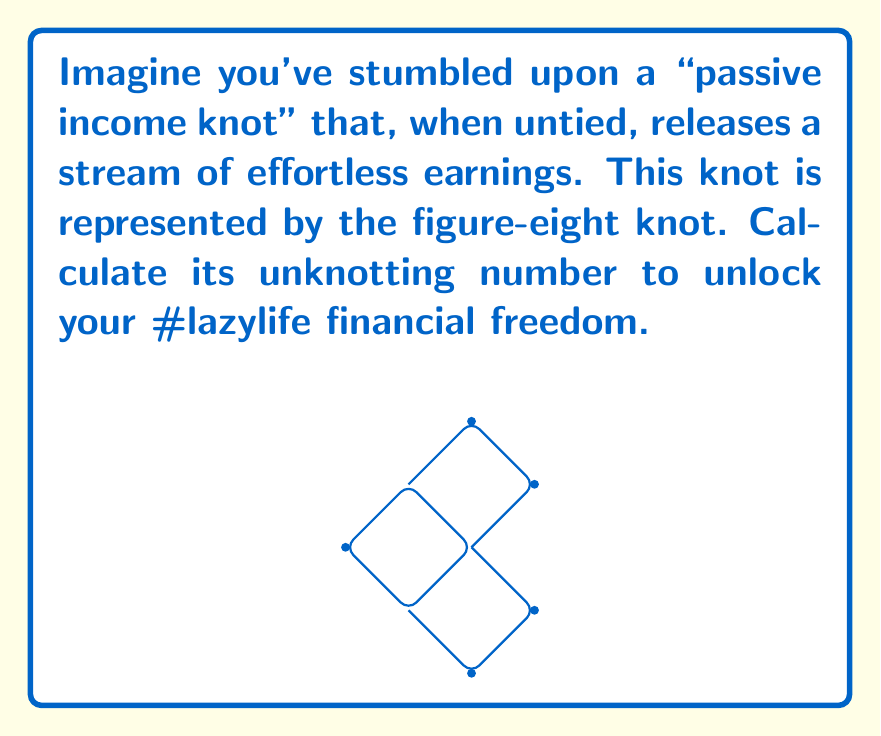Teach me how to tackle this problem. To calculate the unknotting number of the figure-eight knot, we need to follow these steps:

1) The unknotting number of a knot is the minimum number of crossing changes required to transform the knot into an unknot (trivial knot).

2) For the figure-eight knot, we can observe that it has 4 crossings in its standard diagram.

3) However, the unknotting number is not always equal to the number of crossings. We need to find the minimum number of crossings that need to be changed.

4) For the figure-eight knot, it can be proven that changing any one of its crossings is sufficient to unknot it.

5) To visualize this, imagine flipping one of the strands at any crossing. This action effectively "undoes" the knot, resulting in a simple loop (unknot).

6) Mathematically, we can express this as:

   $$u(K) = 1$$

   Where $u(K)$ represents the unknotting number of the figure-eight knot $K$.

7) It's worth noting that the figure-eight knot is amphichiral, meaning it's equivalent to its mirror image. This property contributes to its relatively simple unknotting number.

8) The fact that only one crossing change is needed aligns well with our #lazylife persona - minimum effort for maximum results!
Answer: $1$ 